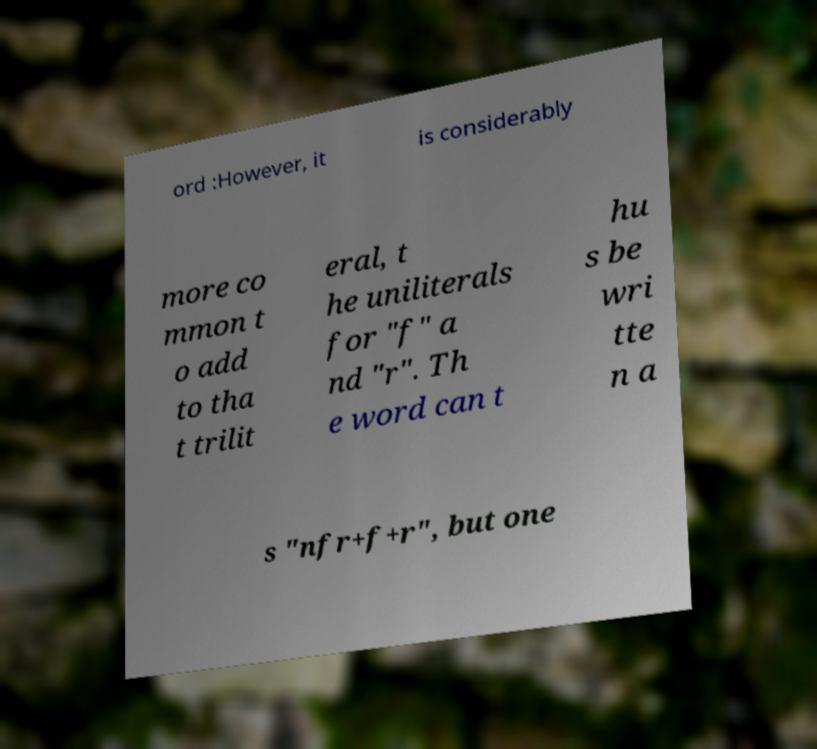Could you assist in decoding the text presented in this image and type it out clearly? ord :However, it is considerably more co mmon t o add to tha t trilit eral, t he uniliterals for "f" a nd "r". Th e word can t hu s be wri tte n a s "nfr+f+r", but one 